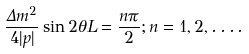Convert formula to latex. <formula><loc_0><loc_0><loc_500><loc_500>\frac { \Delta m ^ { 2 } } { 4 | p | } \sin 2 \theta L = \frac { n \pi } { 2 } ; n = 1 , 2 , \dots .</formula> 